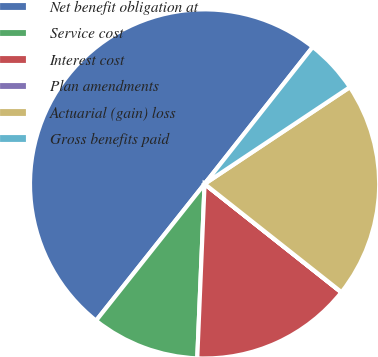Convert chart to OTSL. <chart><loc_0><loc_0><loc_500><loc_500><pie_chart><fcel>Net benefit obligation at<fcel>Service cost<fcel>Interest cost<fcel>Plan amendments<fcel>Actuarial (gain) loss<fcel>Gross benefits paid<nl><fcel>49.96%<fcel>10.01%<fcel>15.0%<fcel>0.02%<fcel>20.0%<fcel>5.01%<nl></chart> 